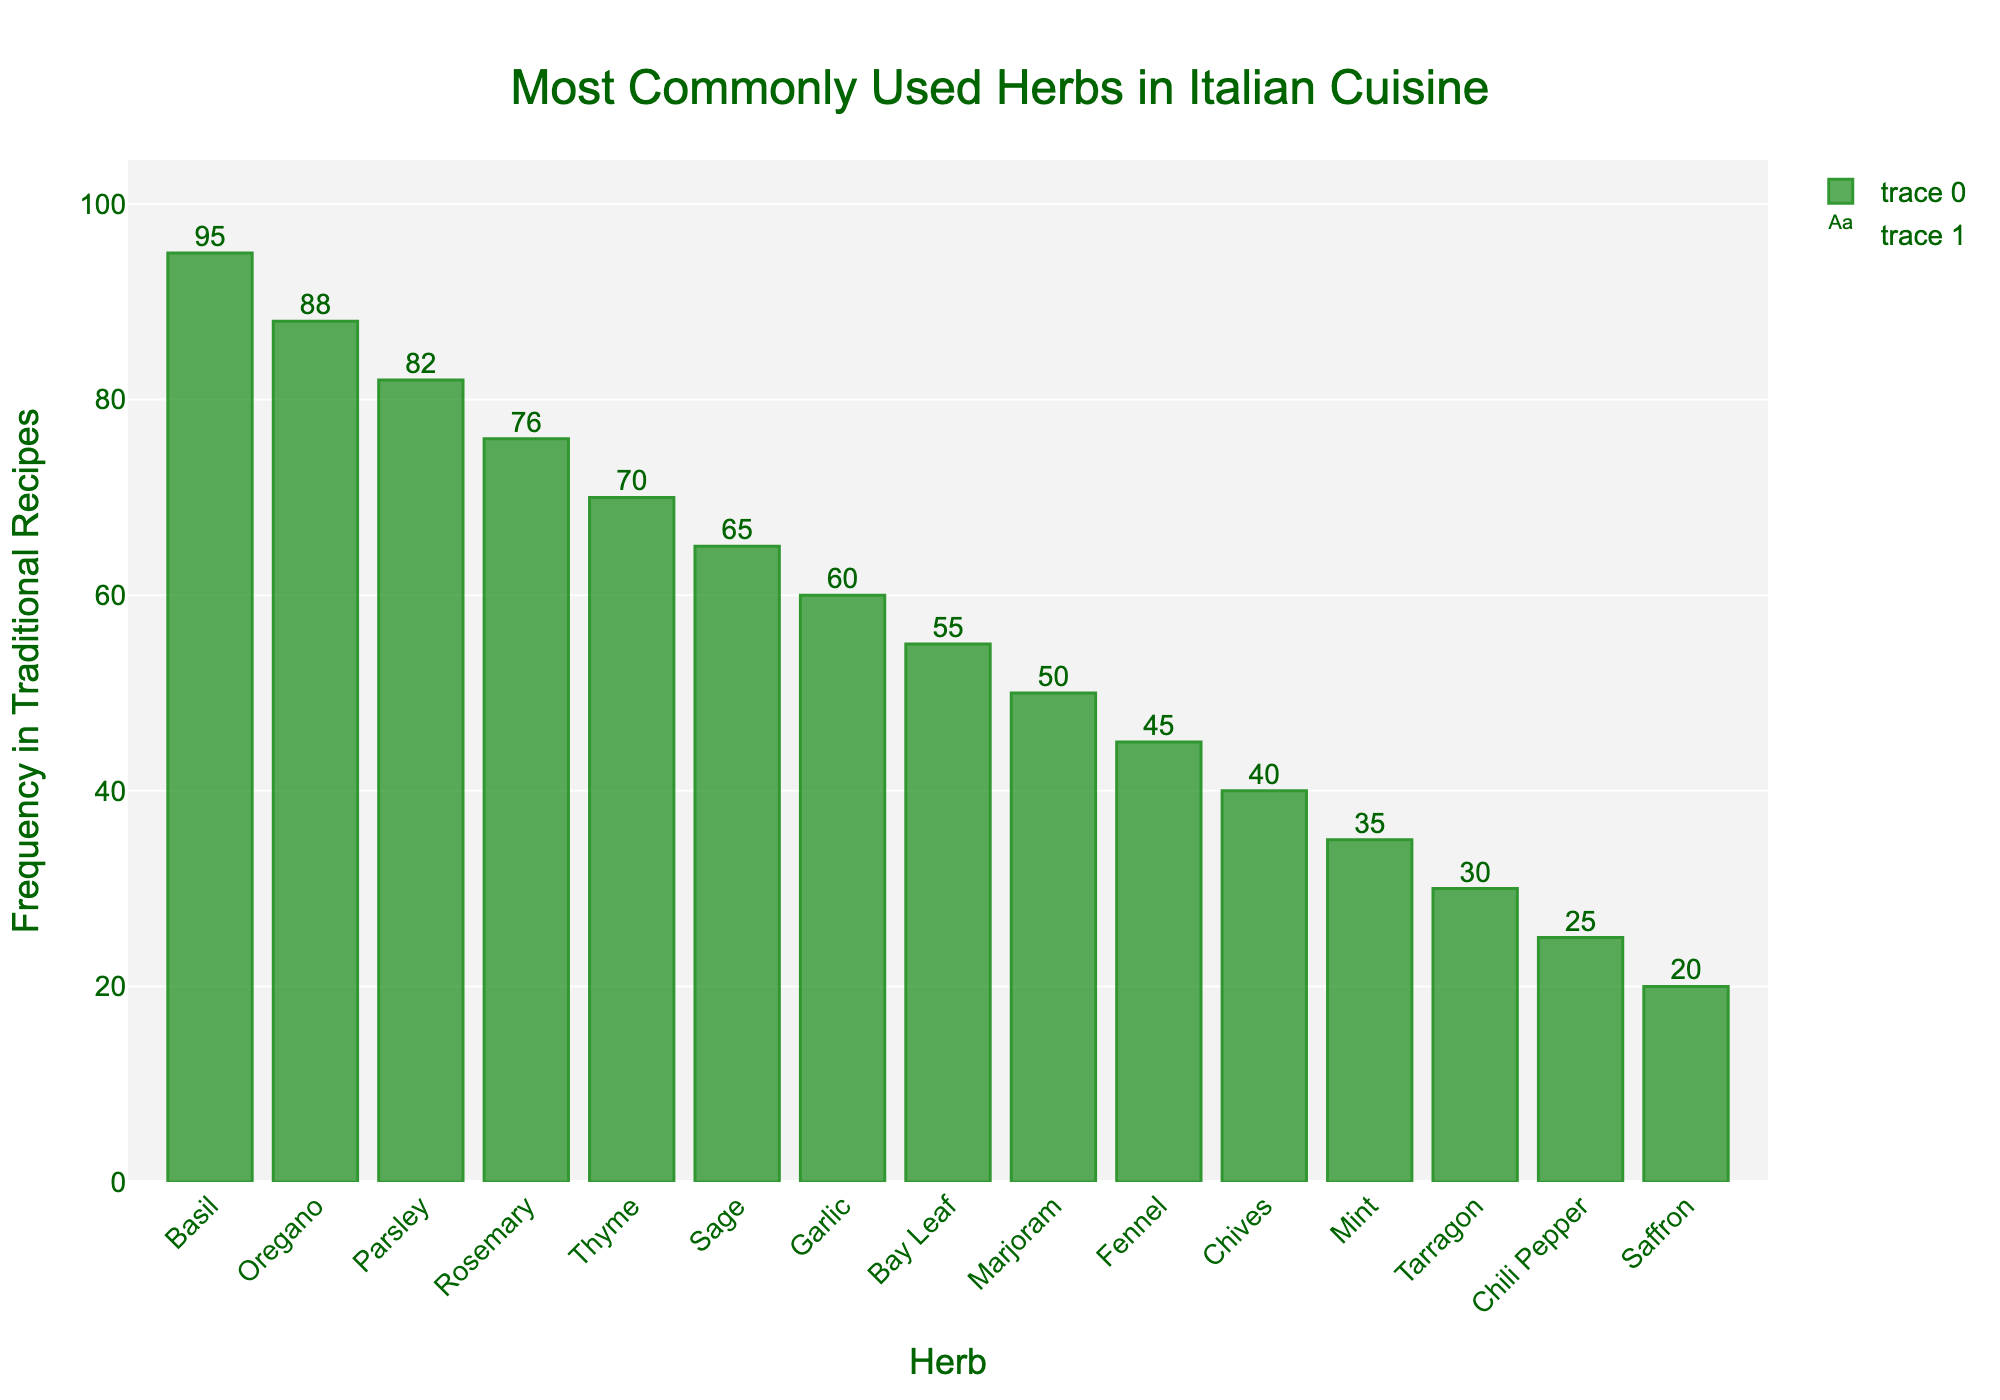Which herb is most commonly used in traditional Italian recipes according to the chart? The highest bar in the chart, which represents Basil, has a frequency of 95, indicating it is the most commonly used herb.
Answer: Basil Which herb has the least frequency of appearance in traditional recipes based on the chart? The shortest bar on the chart, representing Saffron, has a frequency of 20, indicating it is the least frequently used herb.
Answer: Saffron How many more times is Basil used compared to Thyme in traditional recipes? Referring to the bars for Basil and Thyme, Basil is used 95 times and Thyme 70 times. The difference is 95 - 70.
Answer: 25 List two herbs that have a frequency difference of 5. By examining the bars, we can see that the frequencies for Sage and Garlic are 65 and 60 respectively, which have a difference of 5.
Answer: Sage and Garlic What is the combined frequency of the three most common herbs? The three largest bars represent Basil, Oregano, and Parsley, with frequencies of 95, 88, and 82 respectively. Summing them up gives 95 + 88 + 82 = 265.
Answer: 265 Is Parsley used more frequently than Rosemary? By how much? The bar for Parsley shows a frequency of 82, while Rosemary shows 76. So, Parsley is used 82 - 76 times more frequently.
Answer: 6 Which herbs have a frequency below 50? The bars representing herbs with frequencies below 50 are Fennel (45), Chives (40), Mint (35), Tarragon (30), Chili Pepper (25), and Saffron (20).
Answer: Fennel, Chives, Mint, Tarragon, Chili Pepper, and Saffron What is the average frequency of appearance for Thyme, Sage, and Garlic? The frequencies of Thyme, Sage, and Garlic are 70, 65, and 60 respectively. Their average is calculated as (70 + 65 + 60)/3 = 65.
Answer: 65 Which herb is used exactly 50 times according to the chart? The bar that corresponds to a frequency of 50 represents Marjoram.
Answer: Marjoram 